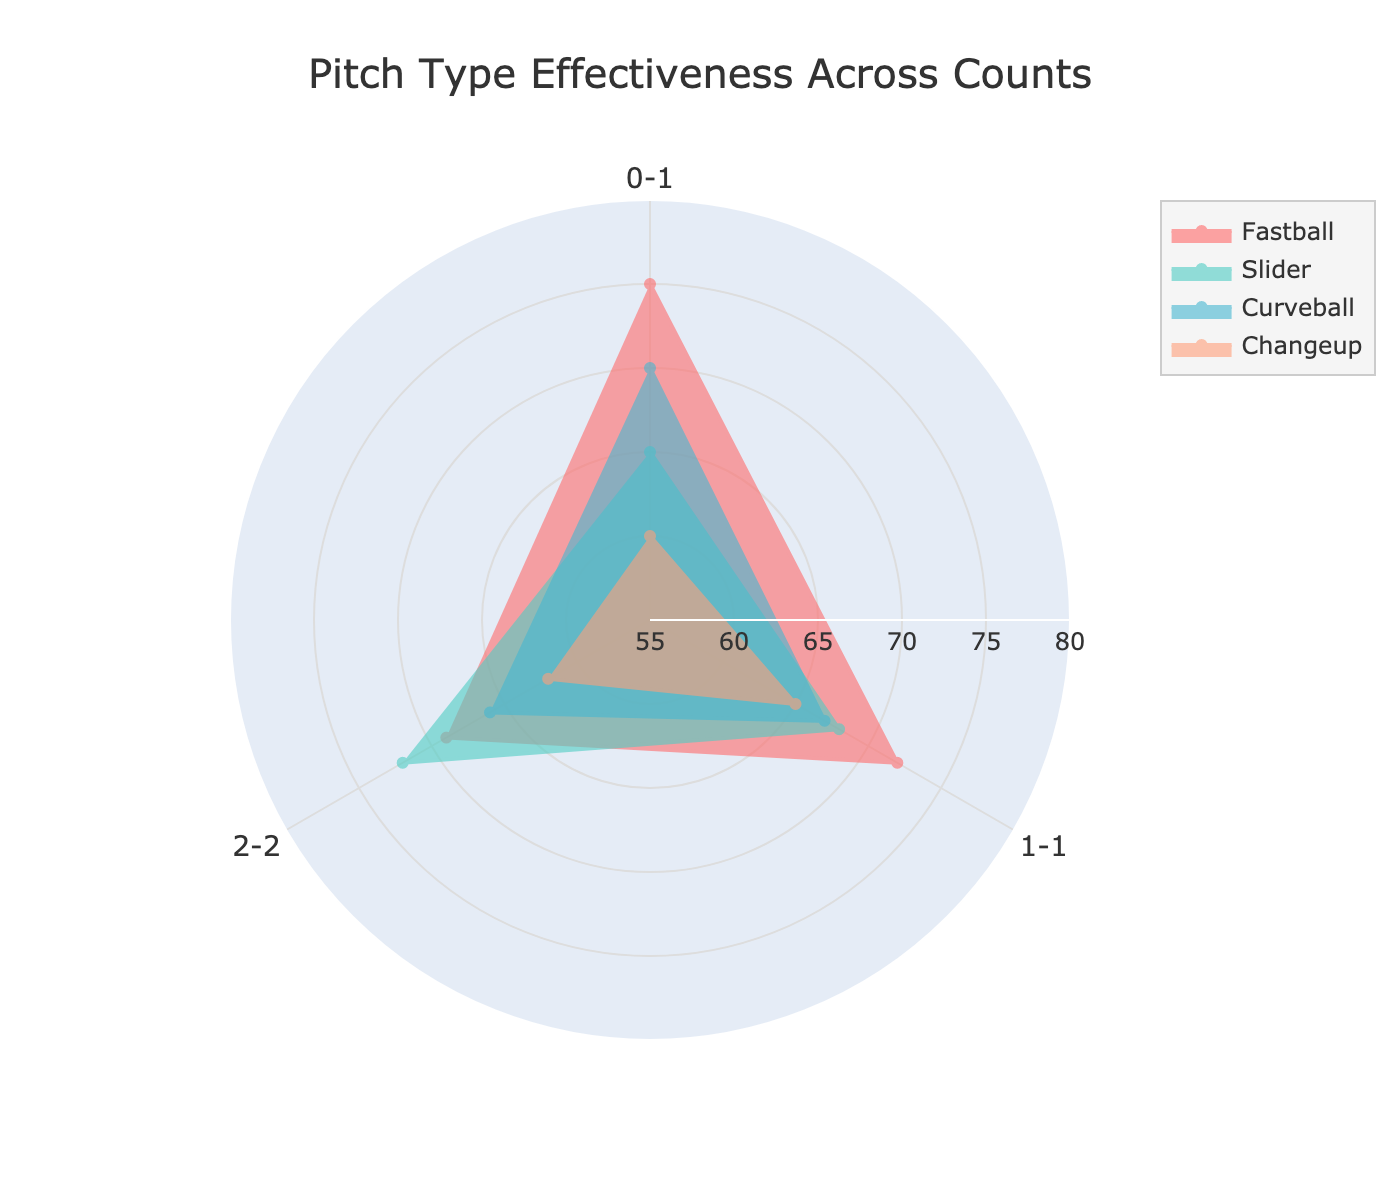How many pitch types are compared in the figure? The radar chart shows different lines/areas for each pitch type, and there are four distinct ones shown.
Answer: Four What is the range of the radial axis? The outer and inner bounds of the shaded areas show the effectiveness values, and the radial axis is labeled from 55 to 80.
Answer: 55 to 80 Which pitch type has the highest effectiveness for the count 2-2? Look at the intersection of each pitch type's line with the axis labeled "2-2." The pitch type that reaches the highest value on the radial axis is the Slider.
Answer: Slider Which count shows the widest variation in effectiveness across pitch types? Comparing the differences in effectiveness at each count (0-1, 1-1, 2-2) by observing the spread of values in the radar chart, the count with the widest spread appears to be 0-1.
Answer: 0-1 What is the average effectiveness of the Curveball across all counts? Sum the Curveball effectiveness values (70 + 67 + 66) and divide by the number of counts (3). The calculation is (70 + 67 + 66)/3 = 67.67.
Answer: 67.67 Is the effectiveness of the Changeup greater than the Slider at any count? Check the intersection points for Changeup and Slider lines with each axis corresponding to the counts. The Slider's effectiveness is higher than the Changeup for all counts, so the Changeup is never greater.
Answer: No Which pitch type shows the most improvement from 0-1 to 2-2 count? Calculate the difference in effectiveness from 0-1 to 2-2 for each pitch type. Slider shows an increase from 65 to 72, which is the largest improvement (+7).
Answer: Slider Based on the radar chart, what is the title of the figure? The title is usually displayed prominently around the top of the chart, and here it is "Pitch Type Effectiveness Across Counts".
Answer: Pitch Type Effectiveness Across Counts Are there any pitch types that have decreasing effectiveness with increasing counts? Observe the trajectory of each pitch type's line from 0-1 to 1-1 to 2-2. Fastball shows a decreasing trend with values of 75, 72, and 69.
Answer: Fastball 